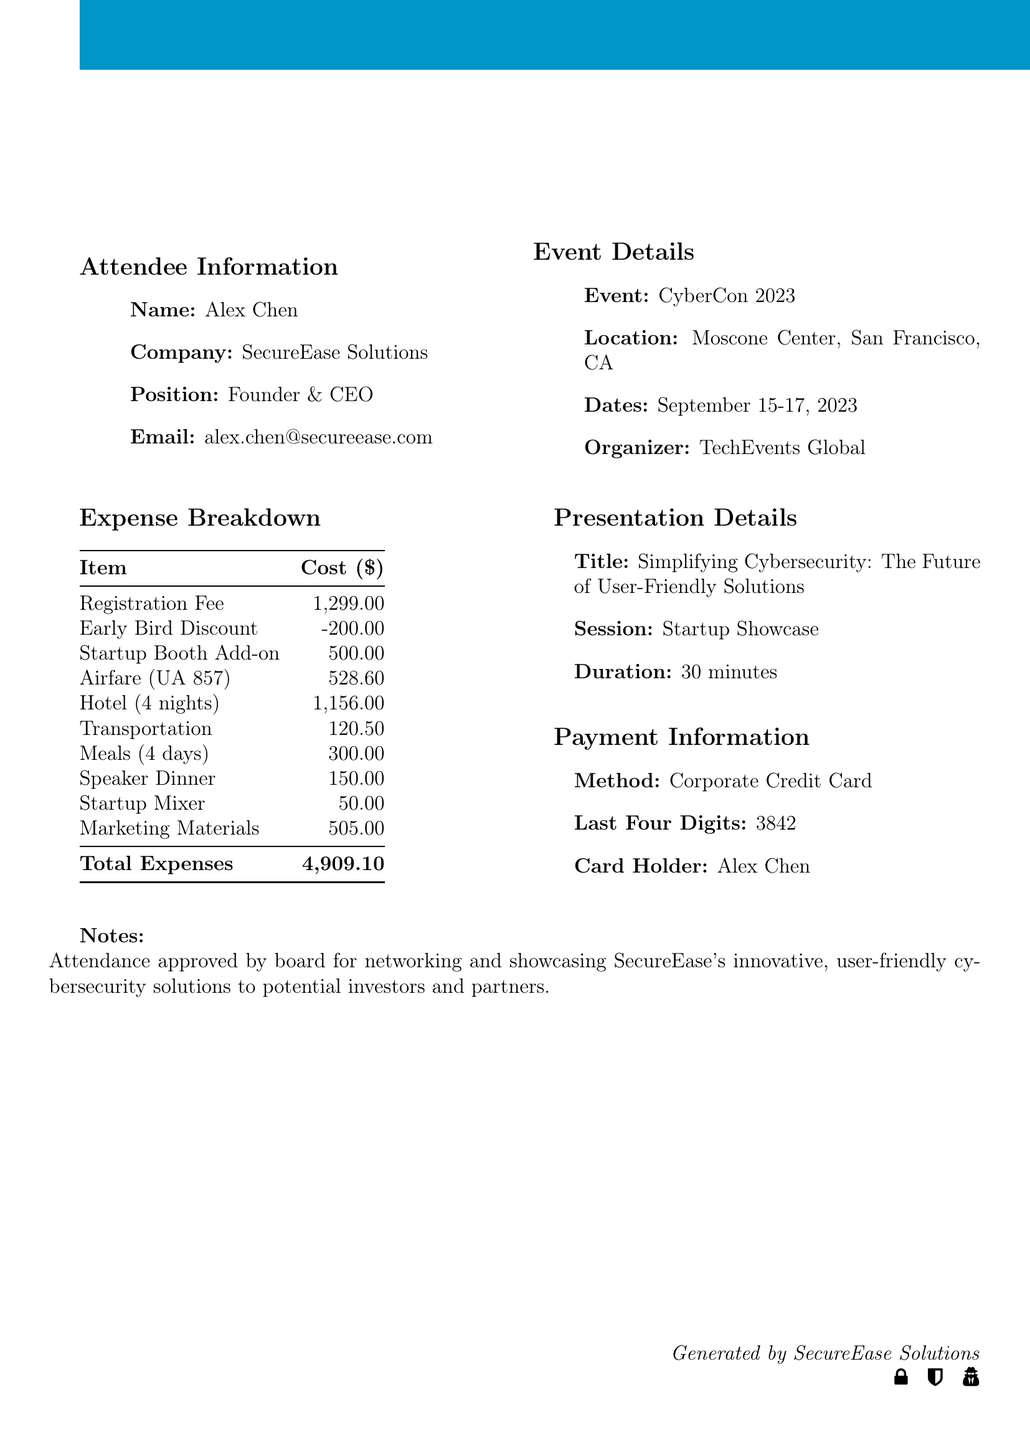What is the event name? The event name is given in the Event Details section of the document.
Answer: CyberCon 2023 What is the total cost of travel expenses? The total cost of travel expenses is broken down in the Expense Breakdown section of the document.
Answer: 2,115.10 Who is the attendee? The attendee's information is listed under Attendee Information section, including name, company, position, and email.
Answer: Alex Chen What type of pass was purchased? The type of registration is found in the Registration section of the document.
Answer: Full Conference Pass How many nights is the hotel stay? The number of nights for the hotel is detailed in the Travel Expenses section under hotel information.
Answer: 4 What was the cost of the startup booth add-on? The cost of the startup booth add-on is mentioned in the Expense Breakdown.
Answer: 500.00 Which airline was used for airfare? The airline name can be found in the travel expenses section related to airfare.
Answer: United Airlines What is the title of the presentation? The title of the presentation is provided in the Presentation Details section of the document.
Answer: Simplifying Cybersecurity: The Future of User-Friendly Solutions What is the cost of the speaker dinner? The cost of the speaker dinner is specified in the Networking section of the document.
Answer: 150.00 